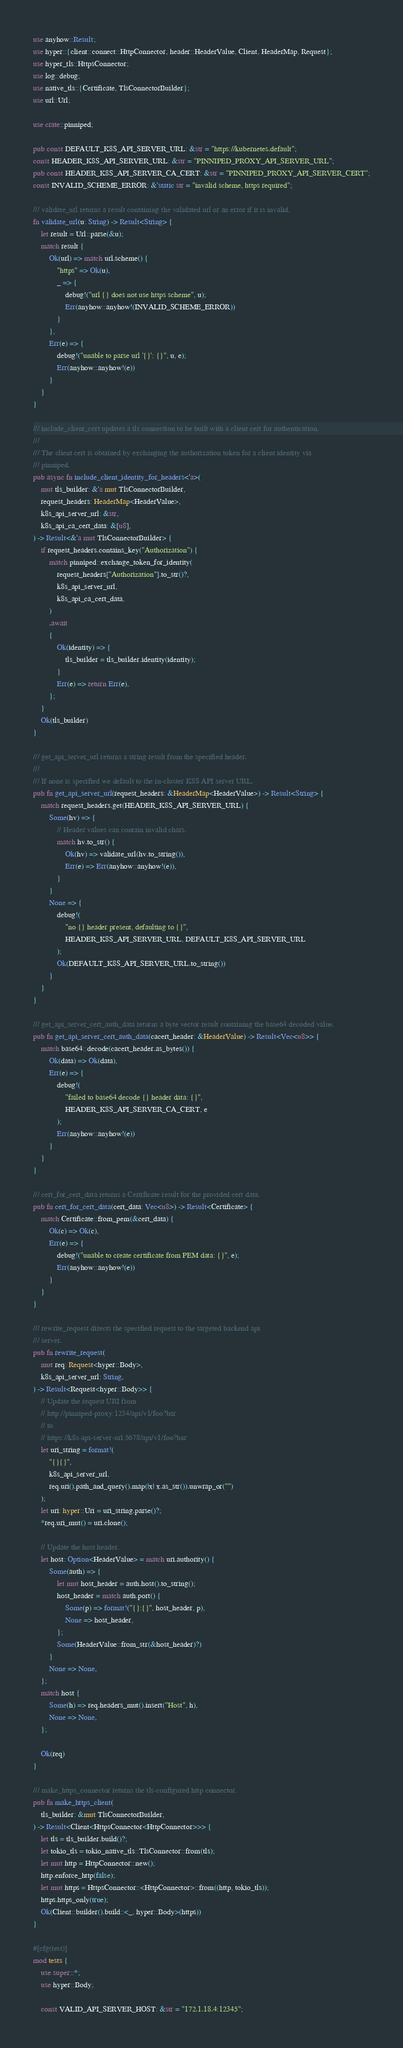<code> <loc_0><loc_0><loc_500><loc_500><_Rust_>use anyhow::Result;
use hyper::{client::connect::HttpConnector, header::HeaderValue, Client, HeaderMap, Request};
use hyper_tls::HttpsConnector;
use log::debug;
use native_tls::{Certificate, TlsConnectorBuilder};
use url::Url;

use crate::pinniped;

pub const DEFAULT_K8S_API_SERVER_URL: &str = "https://kubernetes.default";
const HEADER_K8S_API_SERVER_URL: &str = "PINNIPED_PROXY_API_SERVER_URL";
pub const HEADER_K8S_API_SERVER_CA_CERT: &str = "PINNIPED_PROXY_API_SERVER_CERT";
const INVALID_SCHEME_ERROR: &'static str = "invalid scheme, https required";

/// validate_url returns a result containing the validated url or an error if it is invalid.
fn validate_url(u: String) -> Result<String> {
    let result = Url::parse(&u);
    match result {
        Ok(url) => match url.scheme() {
            "https" => Ok(u),
            _ => {
                debug!("url {} does not use https scheme", u);
                Err(anyhow::anyhow!(INVALID_SCHEME_ERROR))
            }
        },
        Err(e) => {
            debug!("unable to parse url '{}': {}", u, e);
            Err(anyhow::anyhow!(e))
        }
    }
}

/// include_client_cert updates a tls connection to be built with a client cert for authentication.
///
/// The client cert is obtained by exchanging the authorization token for a client identity via
/// pinniped.
pub async fn include_client_identity_for_headers<'a>(
    mut tls_builder: &'a mut TlsConnectorBuilder,
    request_headers: HeaderMap<HeaderValue>,
    k8s_api_server_url: &str,
    k8s_api_ca_cert_data: &[u8],
) -> Result<&'a mut TlsConnectorBuilder> {
    if request_headers.contains_key("Authorization") {
        match pinniped::exchange_token_for_identity(
            request_headers["Authorization"].to_str()?,
            k8s_api_server_url,
            k8s_api_ca_cert_data,
        )
        .await
        {
            Ok(identity) => {
                tls_builder = tls_builder.identity(identity);
            }
            Err(e) => return Err(e),
        };
    }
    Ok(tls_builder)
}

/// get_api_server_url returns a string result from the specified header.
///
/// If none is specified we default to the in-cluster K8S API server URL.
pub fn get_api_server_url(request_headers: &HeaderMap<HeaderValue>) -> Result<String> {
    match request_headers.get(HEADER_K8S_API_SERVER_URL) {
        Some(hv) => {
            // Header values can contain invalid chars.
            match hv.to_str() {
                Ok(hv) => validate_url(hv.to_string()),
                Err(e) => Err(anyhow::anyhow!(e)),
            }
        }
        None => {
            debug!(
                "no {} header present, defaulting to {}",
                HEADER_K8S_API_SERVER_URL, DEFAULT_K8S_API_SERVER_URL
            );
            Ok(DEFAULT_K8S_API_SERVER_URL.to_string())
        }
    }
}

/// get_api_server_cert_auth_data returns a byte vector result containing the base64 decoded value.
pub fn get_api_server_cert_auth_data(cacert_header: &HeaderValue) -> Result<Vec<u8>> {
    match base64::decode(cacert_header.as_bytes()) {
        Ok(data) => Ok(data),
        Err(e) => {
            debug!(
                "failed to base64 decode {} header data: {}",
                HEADER_K8S_API_SERVER_CA_CERT, e
            );
            Err(anyhow::anyhow!(e))
        }
    }
}

/// cert_for_cert_data returns a Certificate result for the provided cert data.
pub fn cert_for_cert_data(cert_data: Vec<u8>) -> Result<Certificate> {
    match Certificate::from_pem(&cert_data) {
        Ok(c) => Ok(c),
        Err(e) => {
            debug!("unable to create certificate from PEM data: {}", e);
            Err(anyhow::anyhow!(e))
        }
    }
}

/// rewrite_request directs the specified request to the targeted backend api
/// server.
pub fn rewrite_request(
    mut req: Request<hyper::Body>,
    k8s_api_server_url: String,
) -> Result<Request<hyper::Body>> {
    // Update the request URI from
    // http://pinniped-proxy:1234/api/v1/foo?bar
    // to
    // https://k8s-api-server-url:5678/api/v1/foo?bar
    let uri_string = format!(
        "{}{}",
        k8s_api_server_url,
        req.uri().path_and_query().map(|x| x.as_str()).unwrap_or("")
    );
    let uri: hyper::Uri = uri_string.parse()?;
    *req.uri_mut() = uri.clone();

    // Update the host header.
    let host: Option<HeaderValue> = match uri.authority() {
        Some(auth) => {
            let mut host_header = auth.host().to_string();
            host_header = match auth.port() {
                Some(p) => format!("{}:{}", host_header, p),
                None => host_header,
            };
            Some(HeaderValue::from_str(&host_header)?)
        }
        None => None,
    };
    match host {
        Some(h) => req.headers_mut().insert("Host", h),
        None => None,
    };

    Ok(req)
}

/// make_https_connector returns the tls-configured http connector.
pub fn make_https_client(
    tls_builder: &mut TlsConnectorBuilder,
) -> Result<Client<HttpsConnector<HttpConnector>>> {
    let tls = tls_builder.build()?;
    let tokio_tls = tokio_native_tls::TlsConnector::from(tls);
    let mut http = HttpConnector::new();
    http.enforce_http(false);
    let mut https = HttpsConnector::<HttpConnector>::from((http, tokio_tls));
    https.https_only(true);
    Ok(Client::builder().build::<_, hyper::Body>(https))
}

#[cfg(test)]
mod tests {
    use super::*;
    use hyper::Body;

    const VALID_API_SERVER_HOST: &str = "172.1.18.4:12345";</code> 